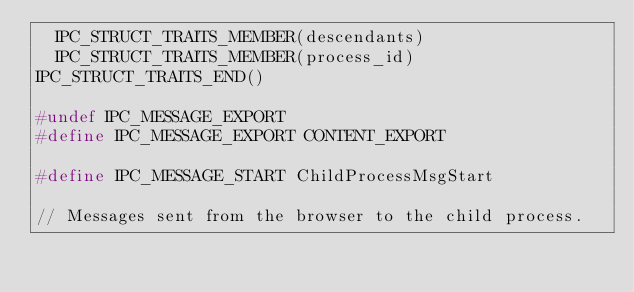<code> <loc_0><loc_0><loc_500><loc_500><_C_>  IPC_STRUCT_TRAITS_MEMBER(descendants)
  IPC_STRUCT_TRAITS_MEMBER(process_id)
IPC_STRUCT_TRAITS_END()

#undef IPC_MESSAGE_EXPORT
#define IPC_MESSAGE_EXPORT CONTENT_EXPORT

#define IPC_MESSAGE_START ChildProcessMsgStart

// Messages sent from the browser to the child process.
</code> 